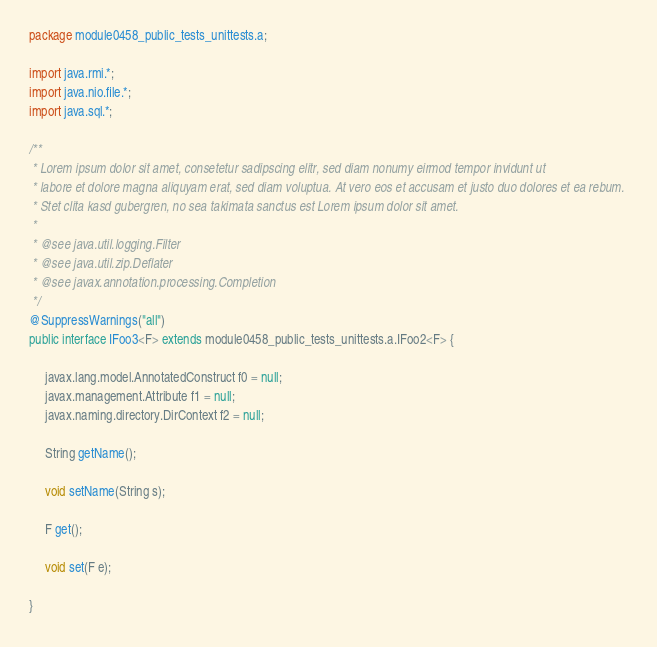<code> <loc_0><loc_0><loc_500><loc_500><_Java_>package module0458_public_tests_unittests.a;

import java.rmi.*;
import java.nio.file.*;
import java.sql.*;

/**
 * Lorem ipsum dolor sit amet, consetetur sadipscing elitr, sed diam nonumy eirmod tempor invidunt ut 
 * labore et dolore magna aliquyam erat, sed diam voluptua. At vero eos et accusam et justo duo dolores et ea rebum. 
 * Stet clita kasd gubergren, no sea takimata sanctus est Lorem ipsum dolor sit amet. 
 *
 * @see java.util.logging.Filter
 * @see java.util.zip.Deflater
 * @see javax.annotation.processing.Completion
 */
@SuppressWarnings("all")
public interface IFoo3<F> extends module0458_public_tests_unittests.a.IFoo2<F> {

	 javax.lang.model.AnnotatedConstruct f0 = null;
	 javax.management.Attribute f1 = null;
	 javax.naming.directory.DirContext f2 = null;

	 String getName();

	 void setName(String s);

	 F get();

	 void set(F e);

}
</code> 